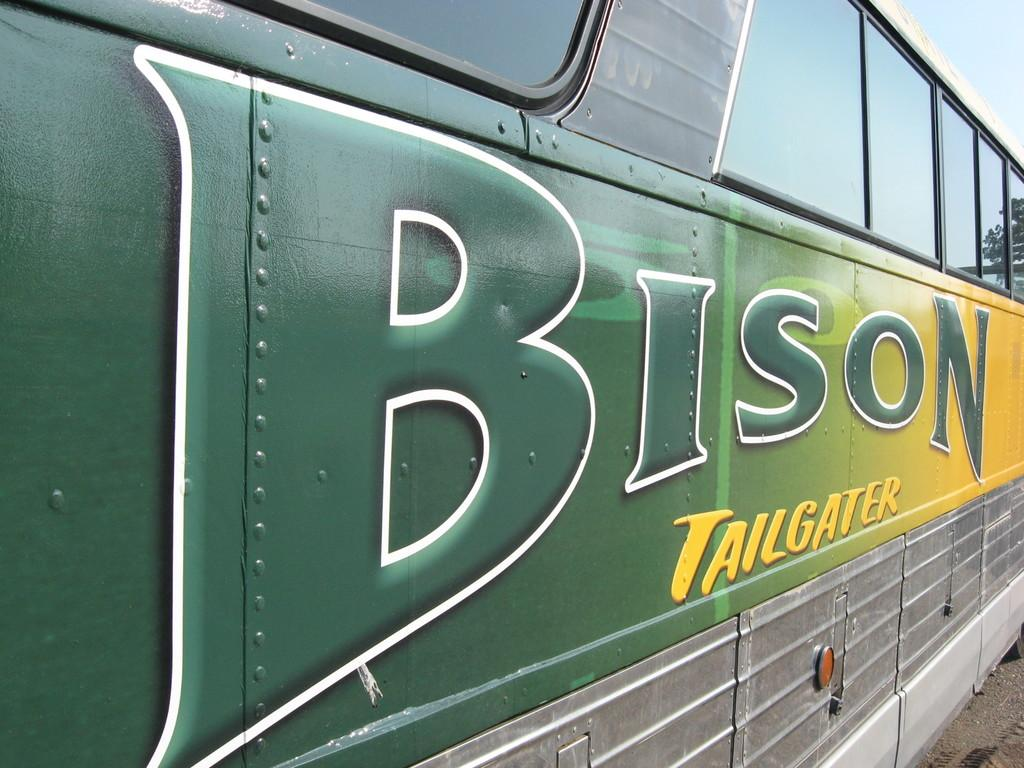<image>
Describe the image concisely. THE SIDE OF GREEN AND YELLOW A BISON TAILGATER BUS 